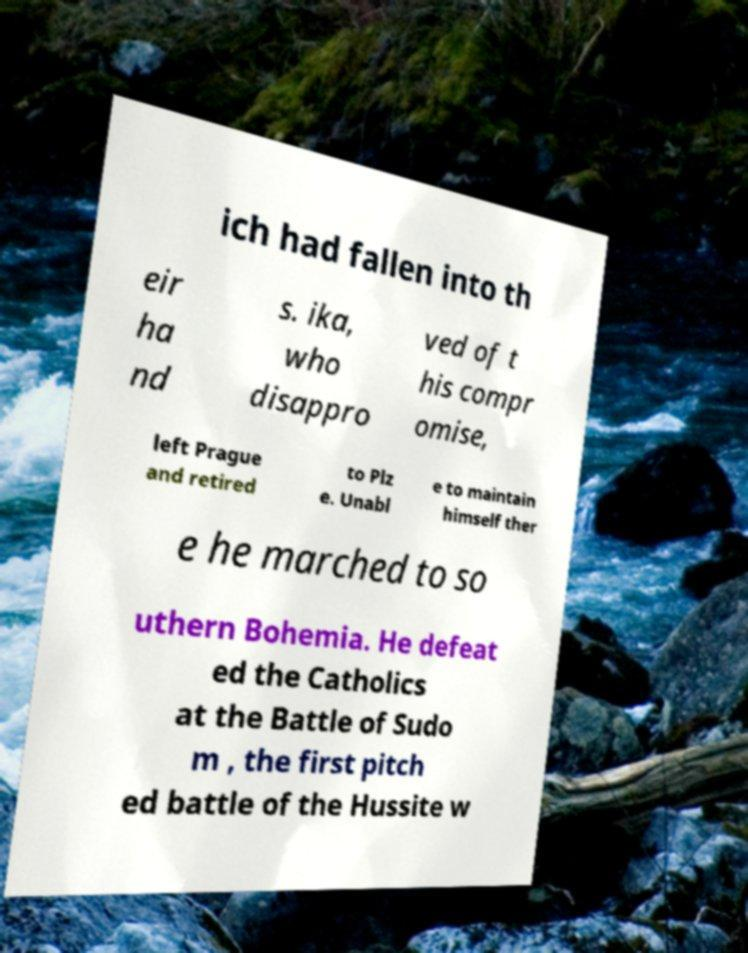Please read and relay the text visible in this image. What does it say? ich had fallen into th eir ha nd s. ika, who disappro ved of t his compr omise, left Prague and retired to Plz e. Unabl e to maintain himself ther e he marched to so uthern Bohemia. He defeat ed the Catholics at the Battle of Sudo m , the first pitch ed battle of the Hussite w 